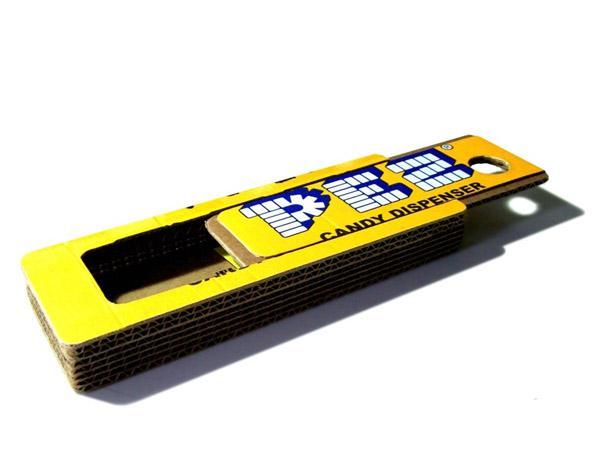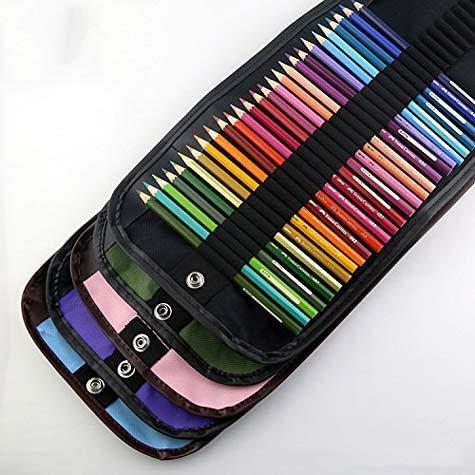The first image is the image on the left, the second image is the image on the right. Evaluate the accuracy of this statement regarding the images: "the case in the image on the left is open". Is it true? Answer yes or no. Yes. The first image is the image on the left, the second image is the image on the right. Evaluate the accuracy of this statement regarding the images: "There is at least one open wooden pencil case.". Is it true? Answer yes or no. No. 